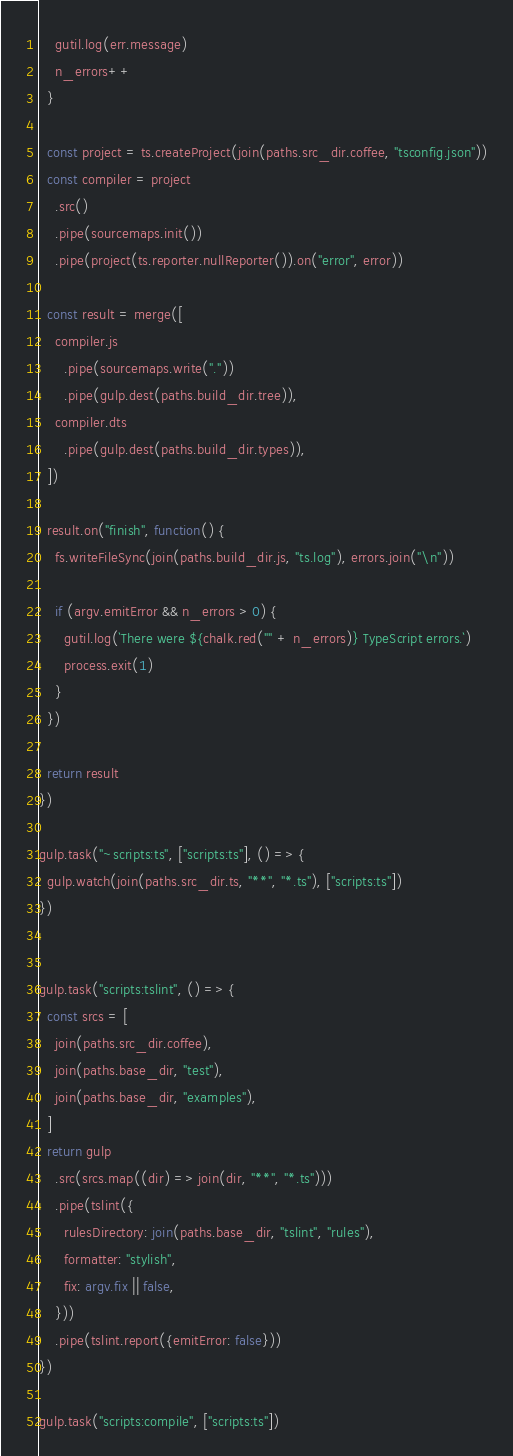<code> <loc_0><loc_0><loc_500><loc_500><_TypeScript_>    gutil.log(err.message)
    n_errors++
  }

  const project = ts.createProject(join(paths.src_dir.coffee, "tsconfig.json"))
  const compiler = project
    .src()
    .pipe(sourcemaps.init())
    .pipe(project(ts.reporter.nullReporter()).on("error", error))

  const result = merge([
    compiler.js
      .pipe(sourcemaps.write("."))
      .pipe(gulp.dest(paths.build_dir.tree)),
    compiler.dts
      .pipe(gulp.dest(paths.build_dir.types)),
  ])

  result.on("finish", function() {
    fs.writeFileSync(join(paths.build_dir.js, "ts.log"), errors.join("\n"))

    if (argv.emitError && n_errors > 0) {
      gutil.log(`There were ${chalk.red("" + n_errors)} TypeScript errors.`)
      process.exit(1)
    }
  })

  return result
})

gulp.task("~scripts:ts", ["scripts:ts"], () => {
  gulp.watch(join(paths.src_dir.ts, "**", "*.ts"), ["scripts:ts"])
})


gulp.task("scripts:tslint", () => {
  const srcs = [
    join(paths.src_dir.coffee),
    join(paths.base_dir, "test"),
    join(paths.base_dir, "examples"),
  ]
  return gulp
    .src(srcs.map((dir) => join(dir, "**", "*.ts")))
    .pipe(tslint({
      rulesDirectory: join(paths.base_dir, "tslint", "rules"),
      formatter: "stylish",
      fix: argv.fix || false,
    }))
    .pipe(tslint.report({emitError: false}))
})

gulp.task("scripts:compile", ["scripts:ts"])
</code> 